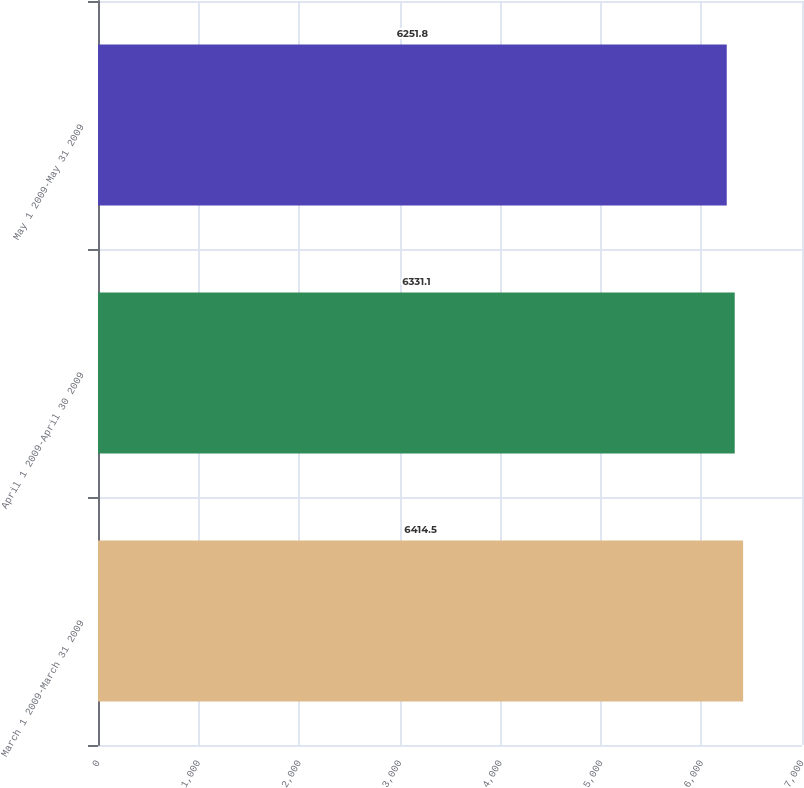Convert chart to OTSL. <chart><loc_0><loc_0><loc_500><loc_500><bar_chart><fcel>March 1 2009-March 31 2009<fcel>April 1 2009-April 30 2009<fcel>May 1 2009-May 31 2009<nl><fcel>6414.5<fcel>6331.1<fcel>6251.8<nl></chart> 